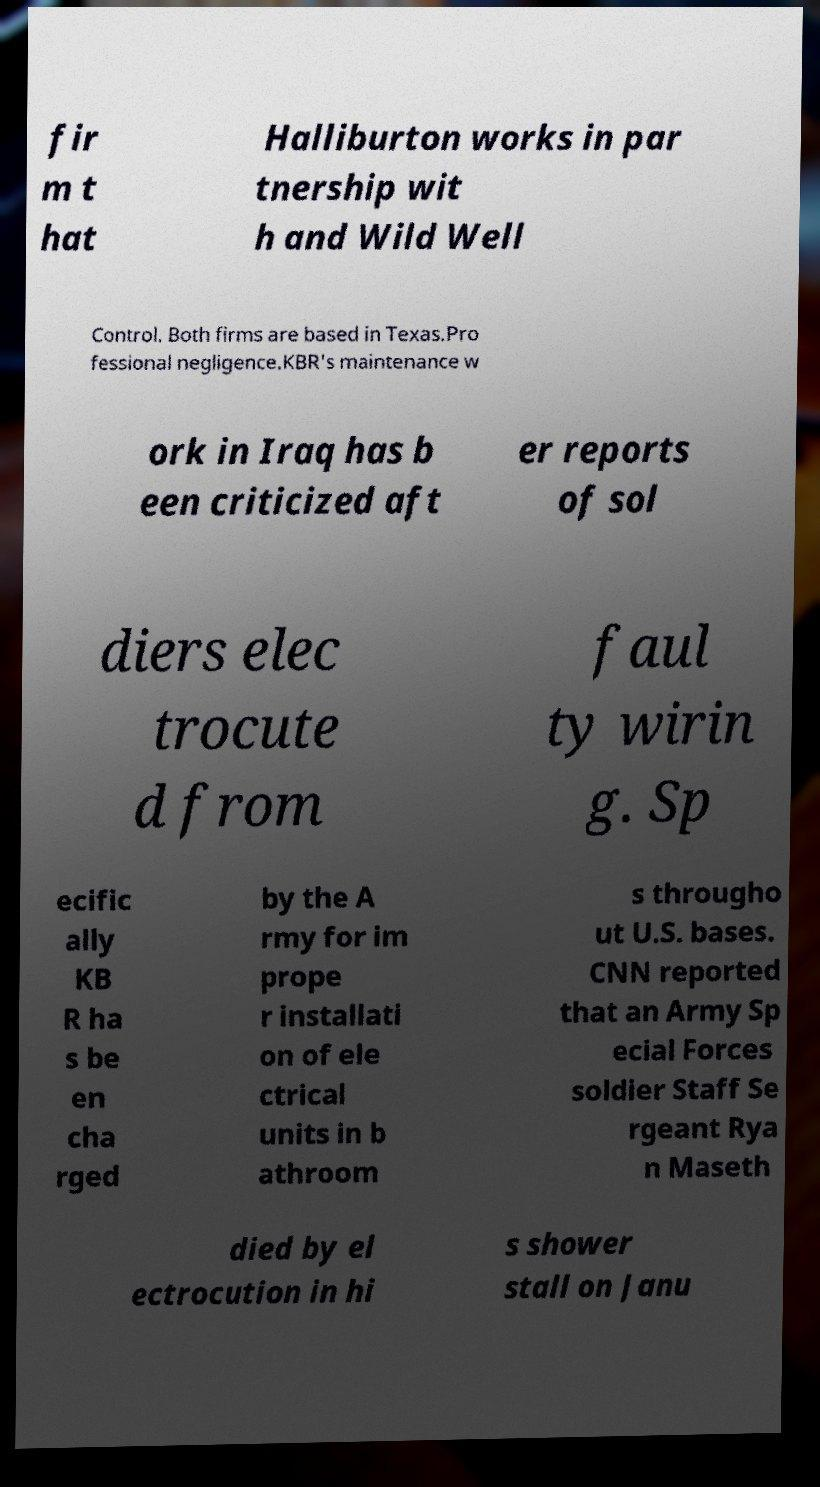Please read and relay the text visible in this image. What does it say? fir m t hat Halliburton works in par tnership wit h and Wild Well Control. Both firms are based in Texas.Pro fessional negligence.KBR's maintenance w ork in Iraq has b een criticized aft er reports of sol diers elec trocute d from faul ty wirin g. Sp ecific ally KB R ha s be en cha rged by the A rmy for im prope r installati on of ele ctrical units in b athroom s througho ut U.S. bases. CNN reported that an Army Sp ecial Forces soldier Staff Se rgeant Rya n Maseth died by el ectrocution in hi s shower stall on Janu 